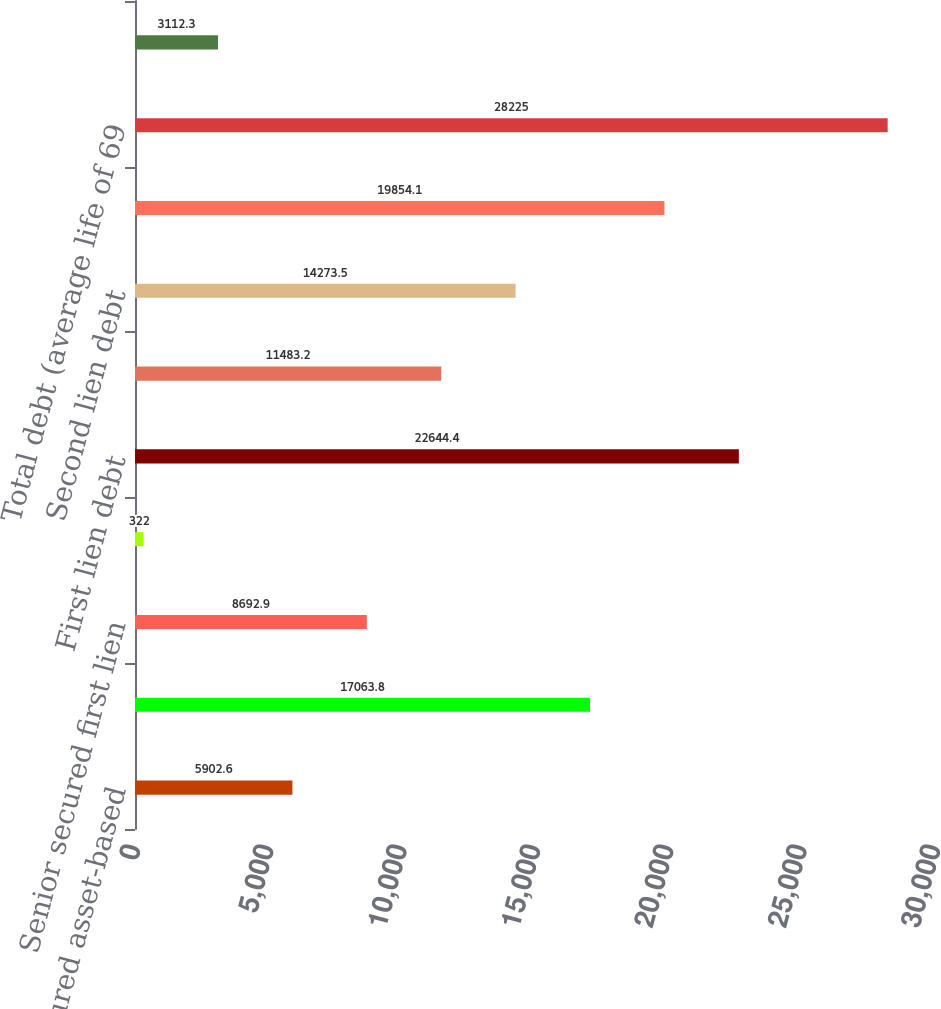Convert chart. <chart><loc_0><loc_0><loc_500><loc_500><bar_chart><fcel>Senior secured asset-based<fcel>Senior secured term loan<fcel>Senior secured first lien<fcel>Other senior secured debt<fcel>First lien debt<fcel>Senior secured second lien<fcel>Second lien debt<fcel>Senior unsecured notes<fcel>Total debt (average life of 69<fcel>Less amounts due within one<nl><fcel>5902.6<fcel>17063.8<fcel>8692.9<fcel>322<fcel>22644.4<fcel>11483.2<fcel>14273.5<fcel>19854.1<fcel>28225<fcel>3112.3<nl></chart> 